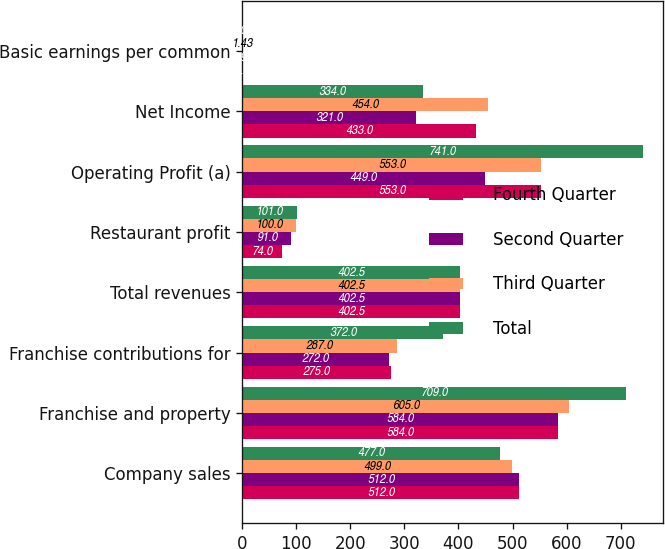Convert chart. <chart><loc_0><loc_0><loc_500><loc_500><stacked_bar_chart><ecel><fcel>Company sales<fcel>Franchise and property<fcel>Franchise contributions for<fcel>Total revenues<fcel>Restaurant profit<fcel>Operating Profit (a)<fcel>Net Income<fcel>Basic earnings per common<nl><fcel>Fourth Quarter<fcel>512<fcel>584<fcel>275<fcel>402.5<fcel>74<fcel>553<fcel>433<fcel>1.3<nl><fcel>Second Quarter<fcel>512<fcel>584<fcel>272<fcel>402.5<fcel>91<fcel>449<fcel>321<fcel>0.99<nl><fcel>Third Quarter<fcel>499<fcel>605<fcel>287<fcel>402.5<fcel>100<fcel>553<fcel>454<fcel>1.43<nl><fcel>Total<fcel>477<fcel>709<fcel>372<fcel>402.5<fcel>101<fcel>741<fcel>334<fcel>1.07<nl></chart> 